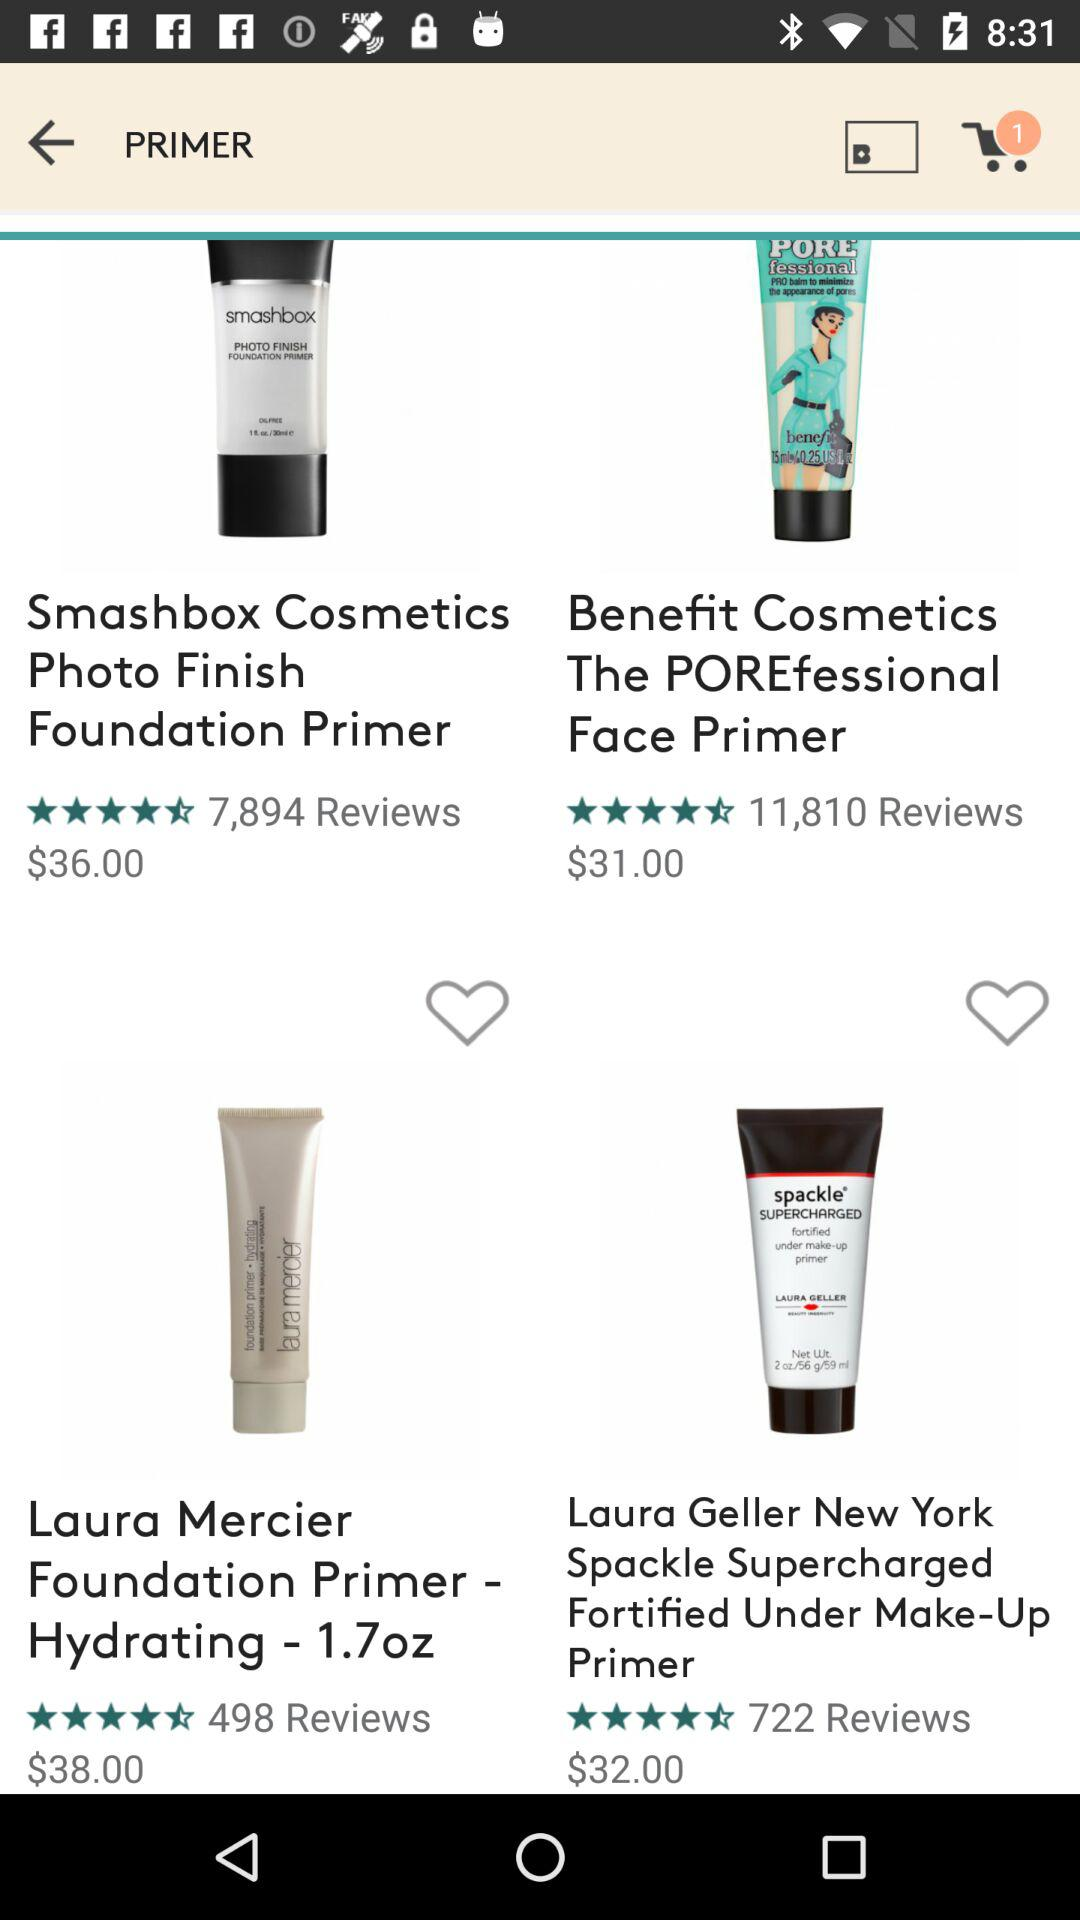How many reviews in Laura Mercier Foundation Primer? There are 498 reviews. 